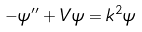<formula> <loc_0><loc_0><loc_500><loc_500>- \psi ^ { \prime \prime } + V \psi = k ^ { 2 } \psi</formula> 